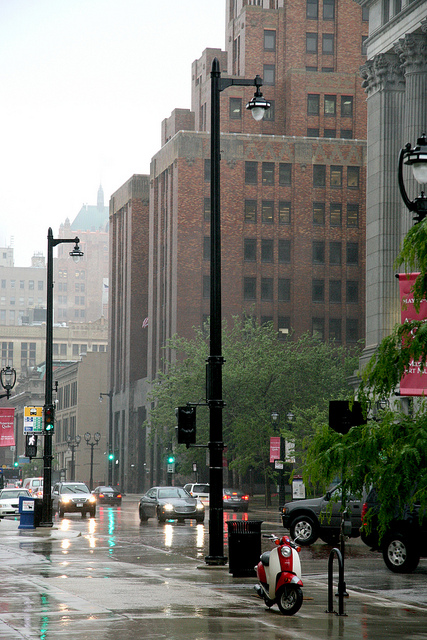<image>How many inches did it rain? It is not sure how many inches it did rain. How many inches did it rain? I don't know how many inches it rained. It can be seen '2' or '1'. 